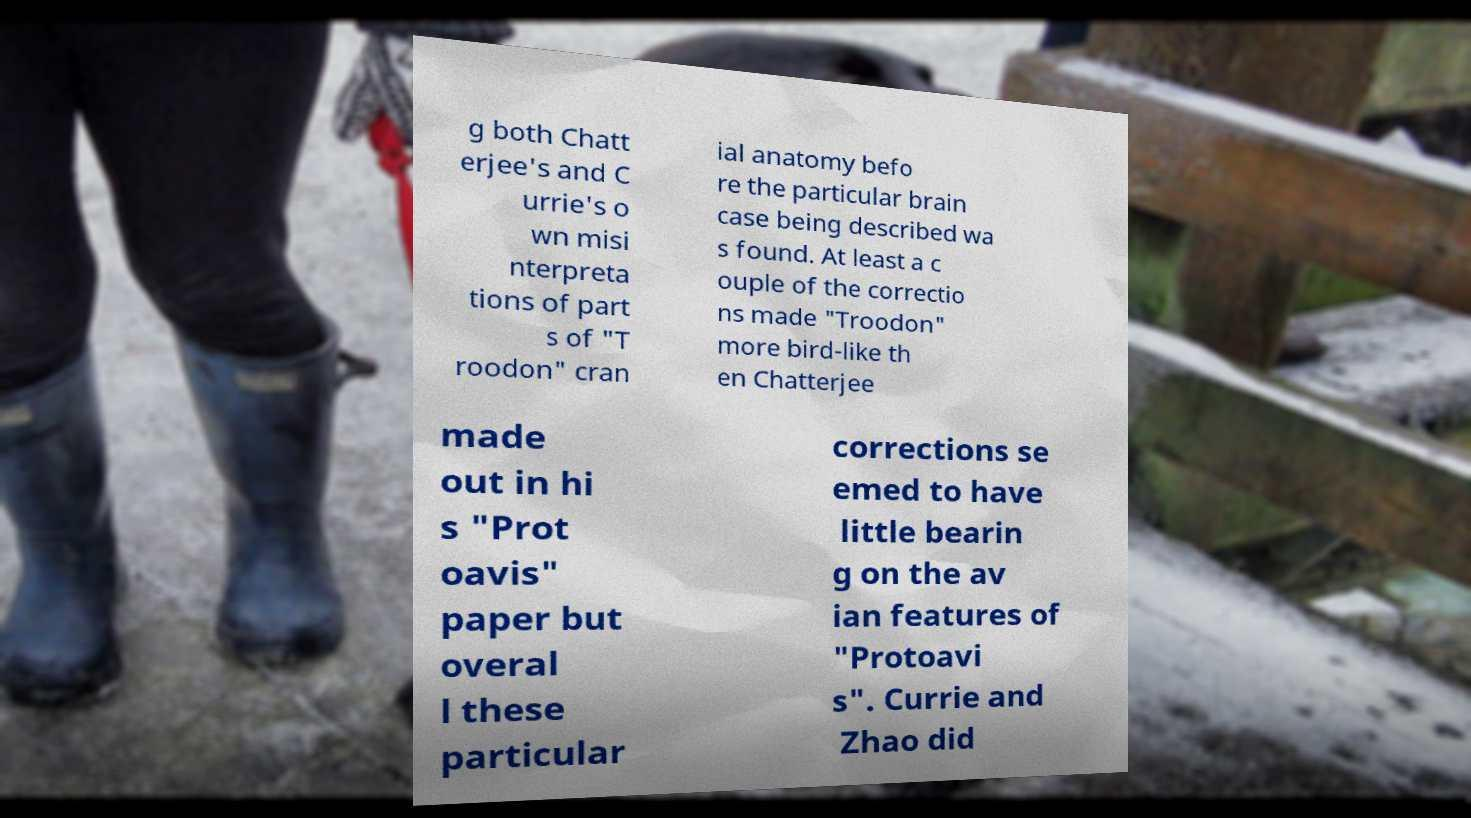Could you extract and type out the text from this image? g both Chatt erjee's and C urrie's o wn misi nterpreta tions of part s of "T roodon" cran ial anatomy befo re the particular brain case being described wa s found. At least a c ouple of the correctio ns made "Troodon" more bird-like th en Chatterjee made out in hi s "Prot oavis" paper but overal l these particular corrections se emed to have little bearin g on the av ian features of "Protoavi s". Currie and Zhao did 